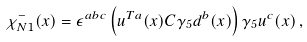<formula> <loc_0><loc_0><loc_500><loc_500>\chi _ { N 1 } ^ { - } ( x ) = \epsilon ^ { a b c } \left ( u ^ { T a } ( x ) C \gamma _ { 5 } d ^ { b } ( x ) \right ) \gamma _ { 5 } u ^ { c } ( x ) \, ,</formula> 